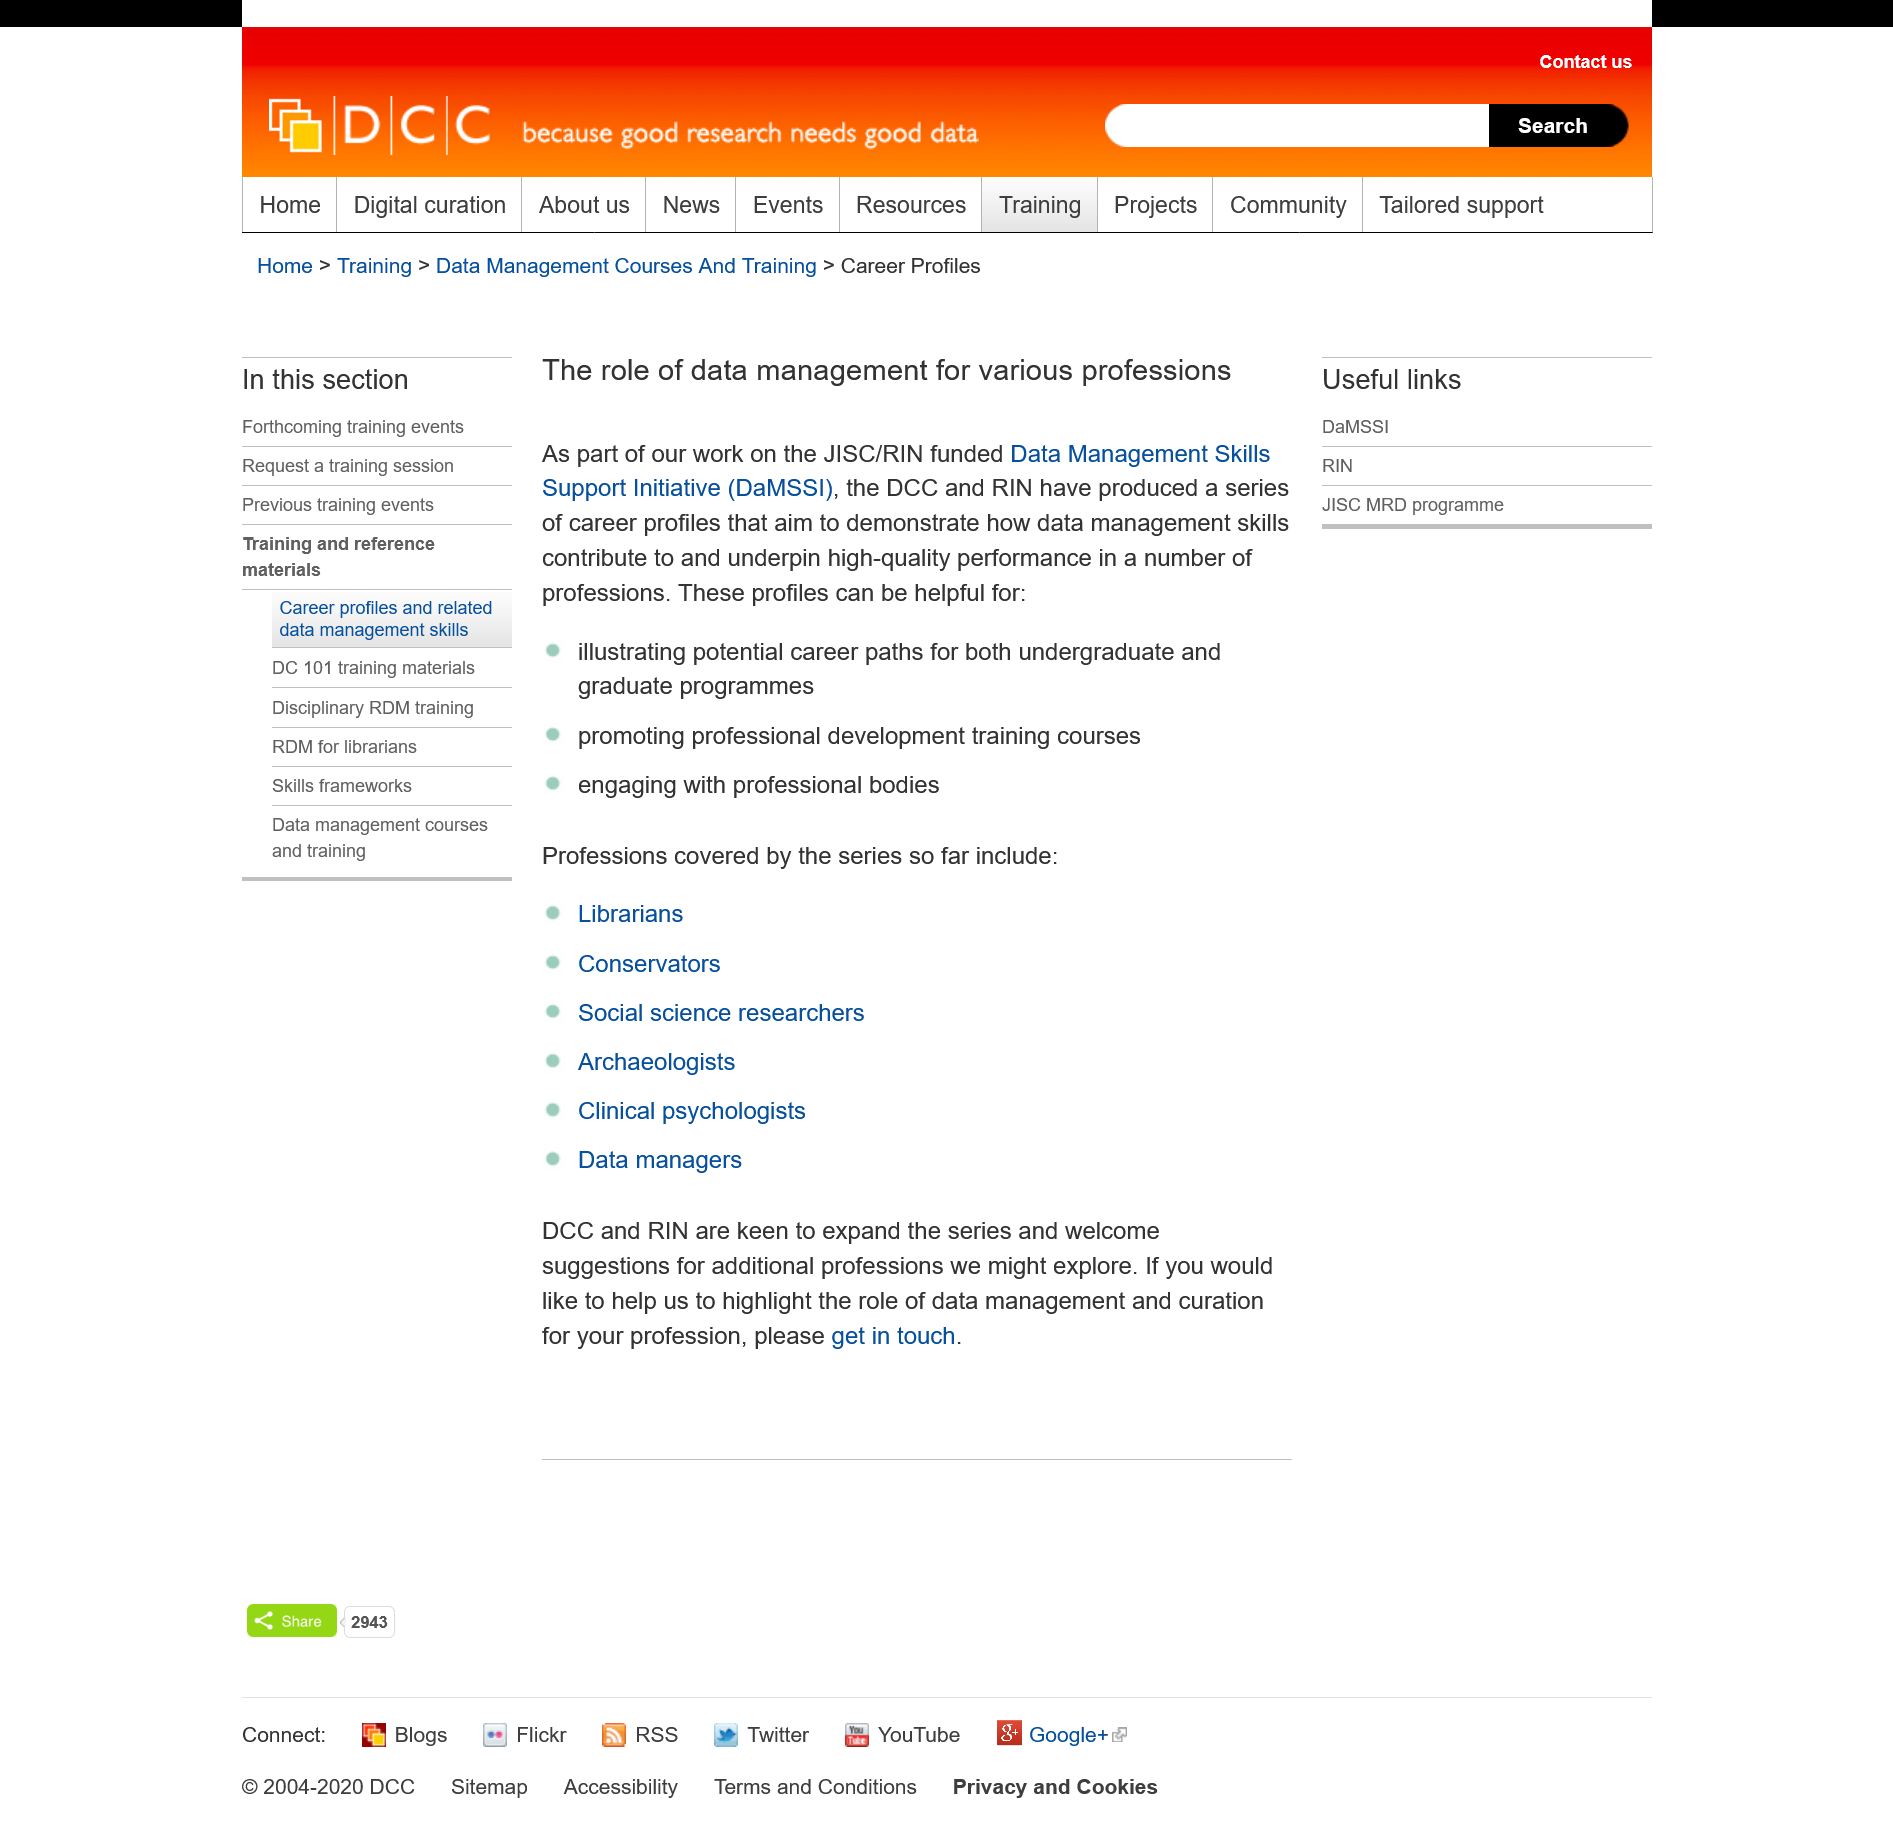List a handful of essential elements in this visual. The Digital Curation Centre (DCC) and the Research Information Network (RIN) have produced a series of career profiles to demonstrate how data management underpins performance in a number of professions. Graduate and undergraduate students can benefit from these profiles by gaining insight into potential career paths and inspiration for their own career development. The Data Management Skills Support Initiative has created a series of career profiles using data management skills to promote professional development training courses. 